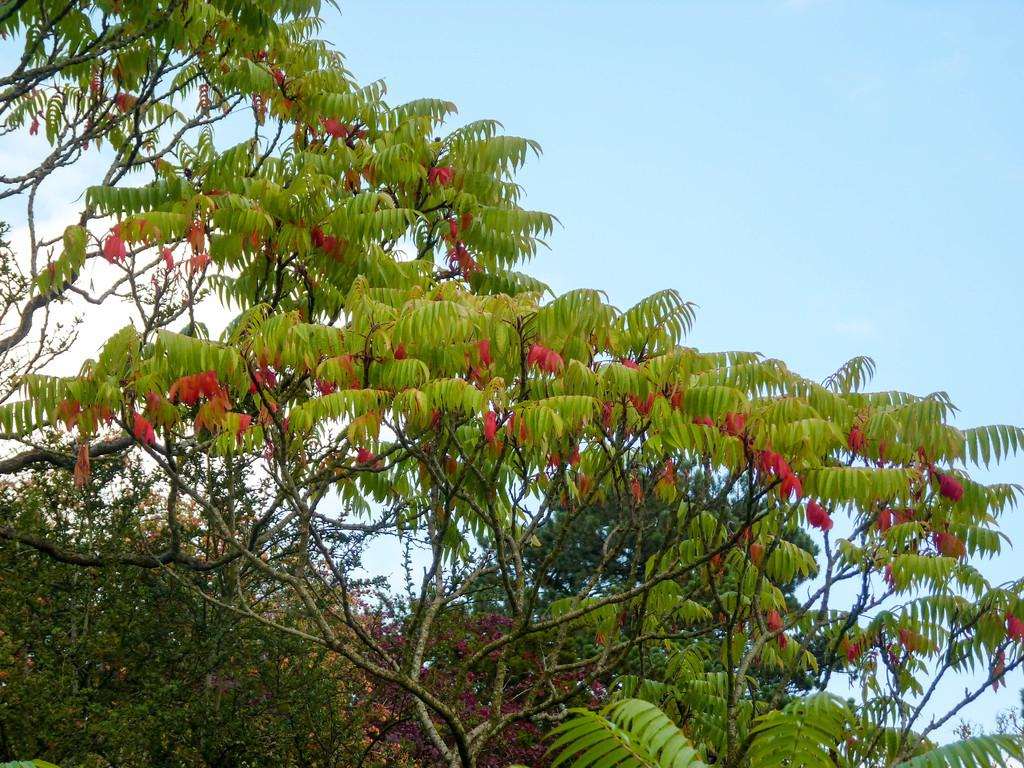What is visible in the background of the image? The sky is visible in the image. What can be seen in the sky in the image? Clouds are present in the image. What type of natural environment is visible in the image? Trees are visible in the image. What type of science experiment can be seen taking place in the image? There is no science experiment present in the image; it features the sky, clouds, and trees. Where is the playground located in the image? There is no playground present in the image. 